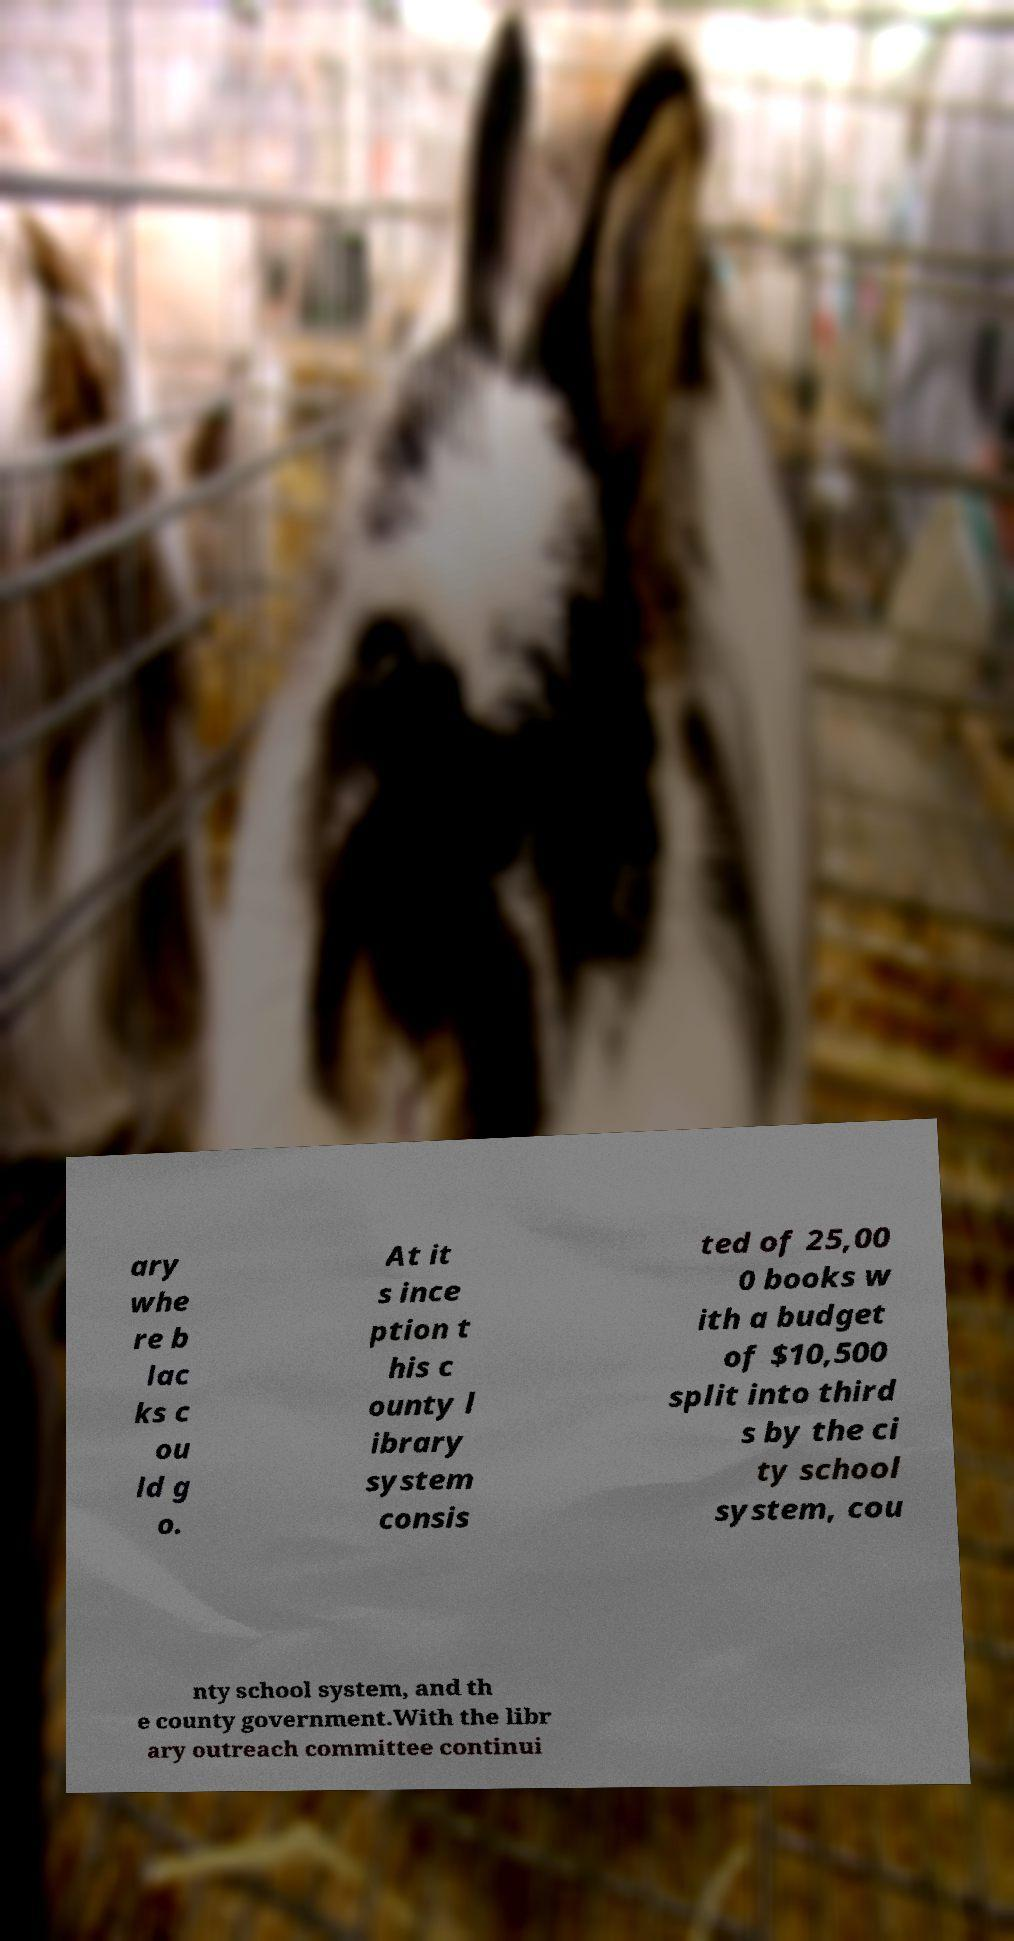What messages or text are displayed in this image? I need them in a readable, typed format. ary whe re b lac ks c ou ld g o. At it s ince ption t his c ounty l ibrary system consis ted of 25,00 0 books w ith a budget of $10,500 split into third s by the ci ty school system, cou nty school system, and th e county government.With the libr ary outreach committee continui 